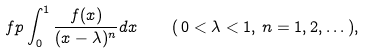<formula> <loc_0><loc_0><loc_500><loc_500>\ f p \int _ { 0 } ^ { 1 } \frac { f ( x ) } { ( x - \lambda ) ^ { n } } d x \quad ( \, 0 < \lambda < 1 , \, n = 1 , 2 , \dots \, ) ,</formula> 